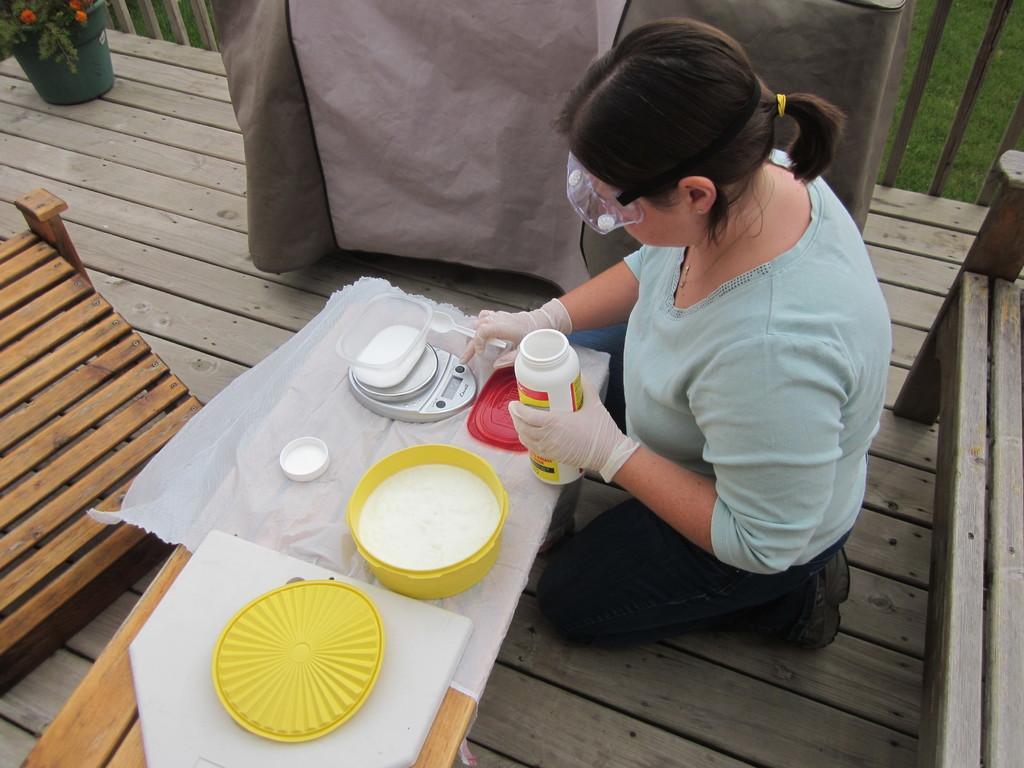In one or two sentences, can you explain what this image depicts? In this image I can see a woman sitting on her knees on the wooden platform holding a jar and there are containers, a lid on the wooden desk. There is a wooden object, in the top right corner there is a wooden fence and grass, in the top left there is a flower pot and at the top center there is a piece of cloth. 